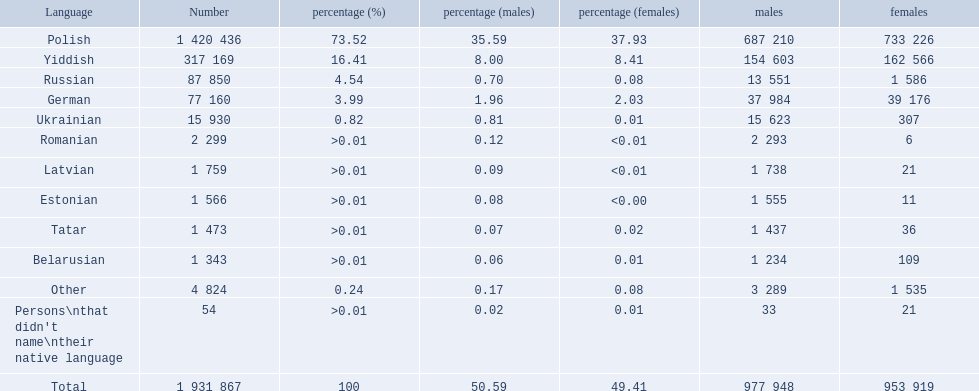What are all the languages? Polish, Yiddish, Russian, German, Ukrainian, Romanian, Latvian, Estonian, Tatar, Belarusian, Other. Which only have percentages >0.01? Romanian, Latvian, Estonian, Tatar, Belarusian. Of these, which has the greatest number of speakers? Romanian. 